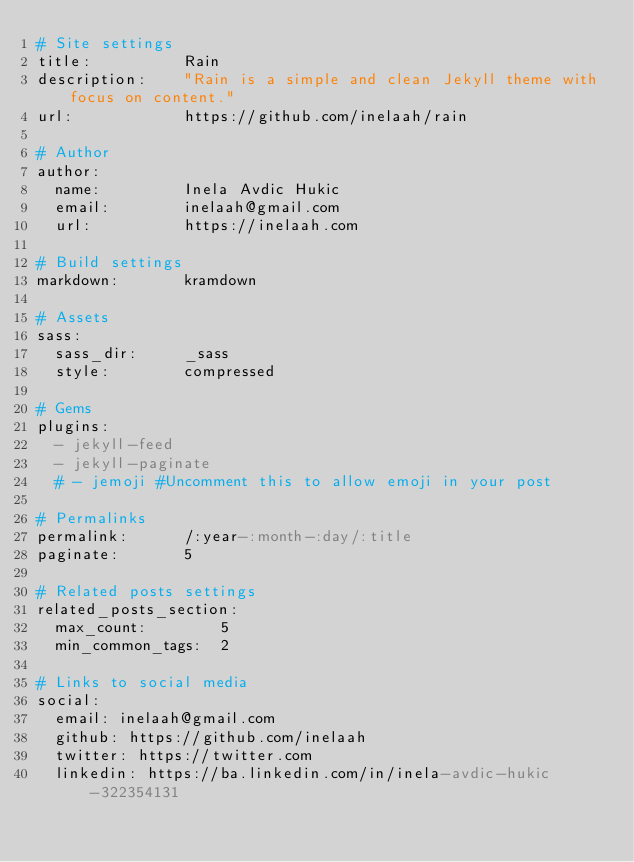Convert code to text. <code><loc_0><loc_0><loc_500><loc_500><_YAML_># Site settings
title:          Rain
description:    "Rain is a simple and clean Jekyll theme with focus on content."
url:            https://github.com/inelaah/rain

# Author
author:
  name:         Inela Avdic Hukic
  email:        inelaah@gmail.com
  url:          https://inelaah.com

# Build settings
markdown:       kramdown

# Assets
sass:
  sass_dir:     _sass
  style:        compressed

# Gems
plugins:
  - jekyll-feed
  - jekyll-paginate
  # - jemoji #Uncomment this to allow emoji in your post

# Permalinks
permalink:      /:year-:month-:day/:title
paginate:       5

# Related posts settings
related_posts_section:
  max_count:        5
  min_common_tags:  2

# Links to social media
social:
  email: inelaah@gmail.com
  github: https://github.com/inelaah
  twitter: https://twitter.com
  linkedin: https://ba.linkedin.com/in/inela-avdic-hukic-322354131
</code> 